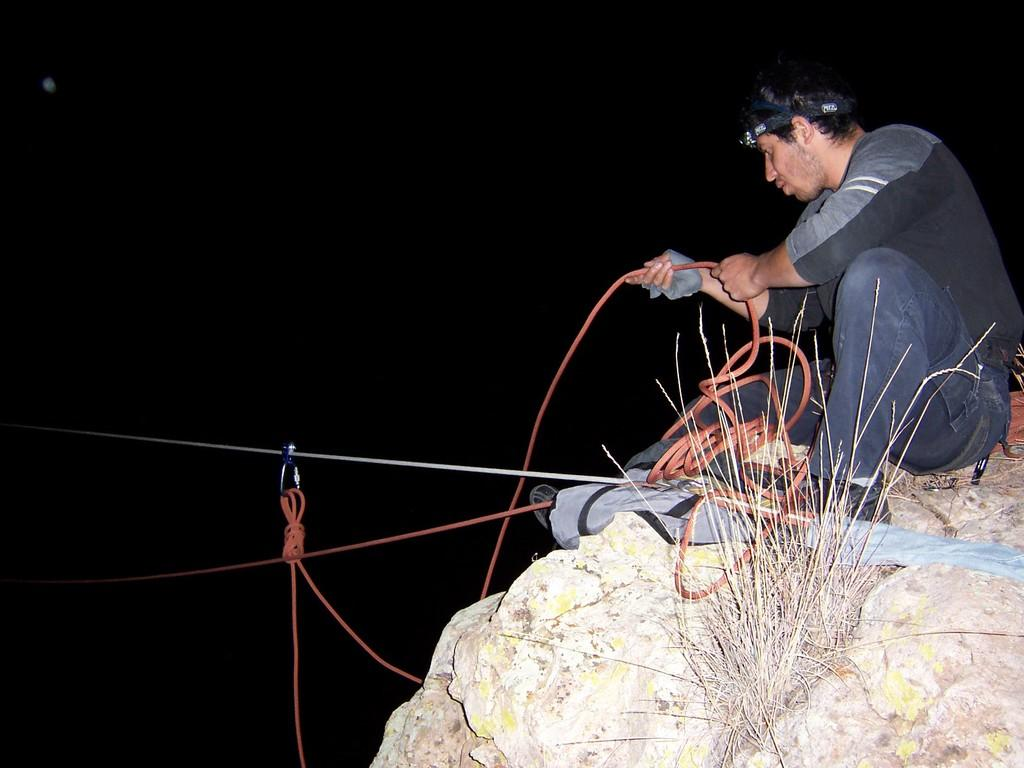Who is present in the image? There is a man in the image. What is the man doing in the image? The man is sitting on a rock. What is the man holding in the image? The man is holding a rope. What type of vegetation can be seen in the image? There is grass visible in the image. What type of robin is perched on the man's shoulder in the image? There is no robin present in the image; the man is holding a rope and sitting on a rock. 